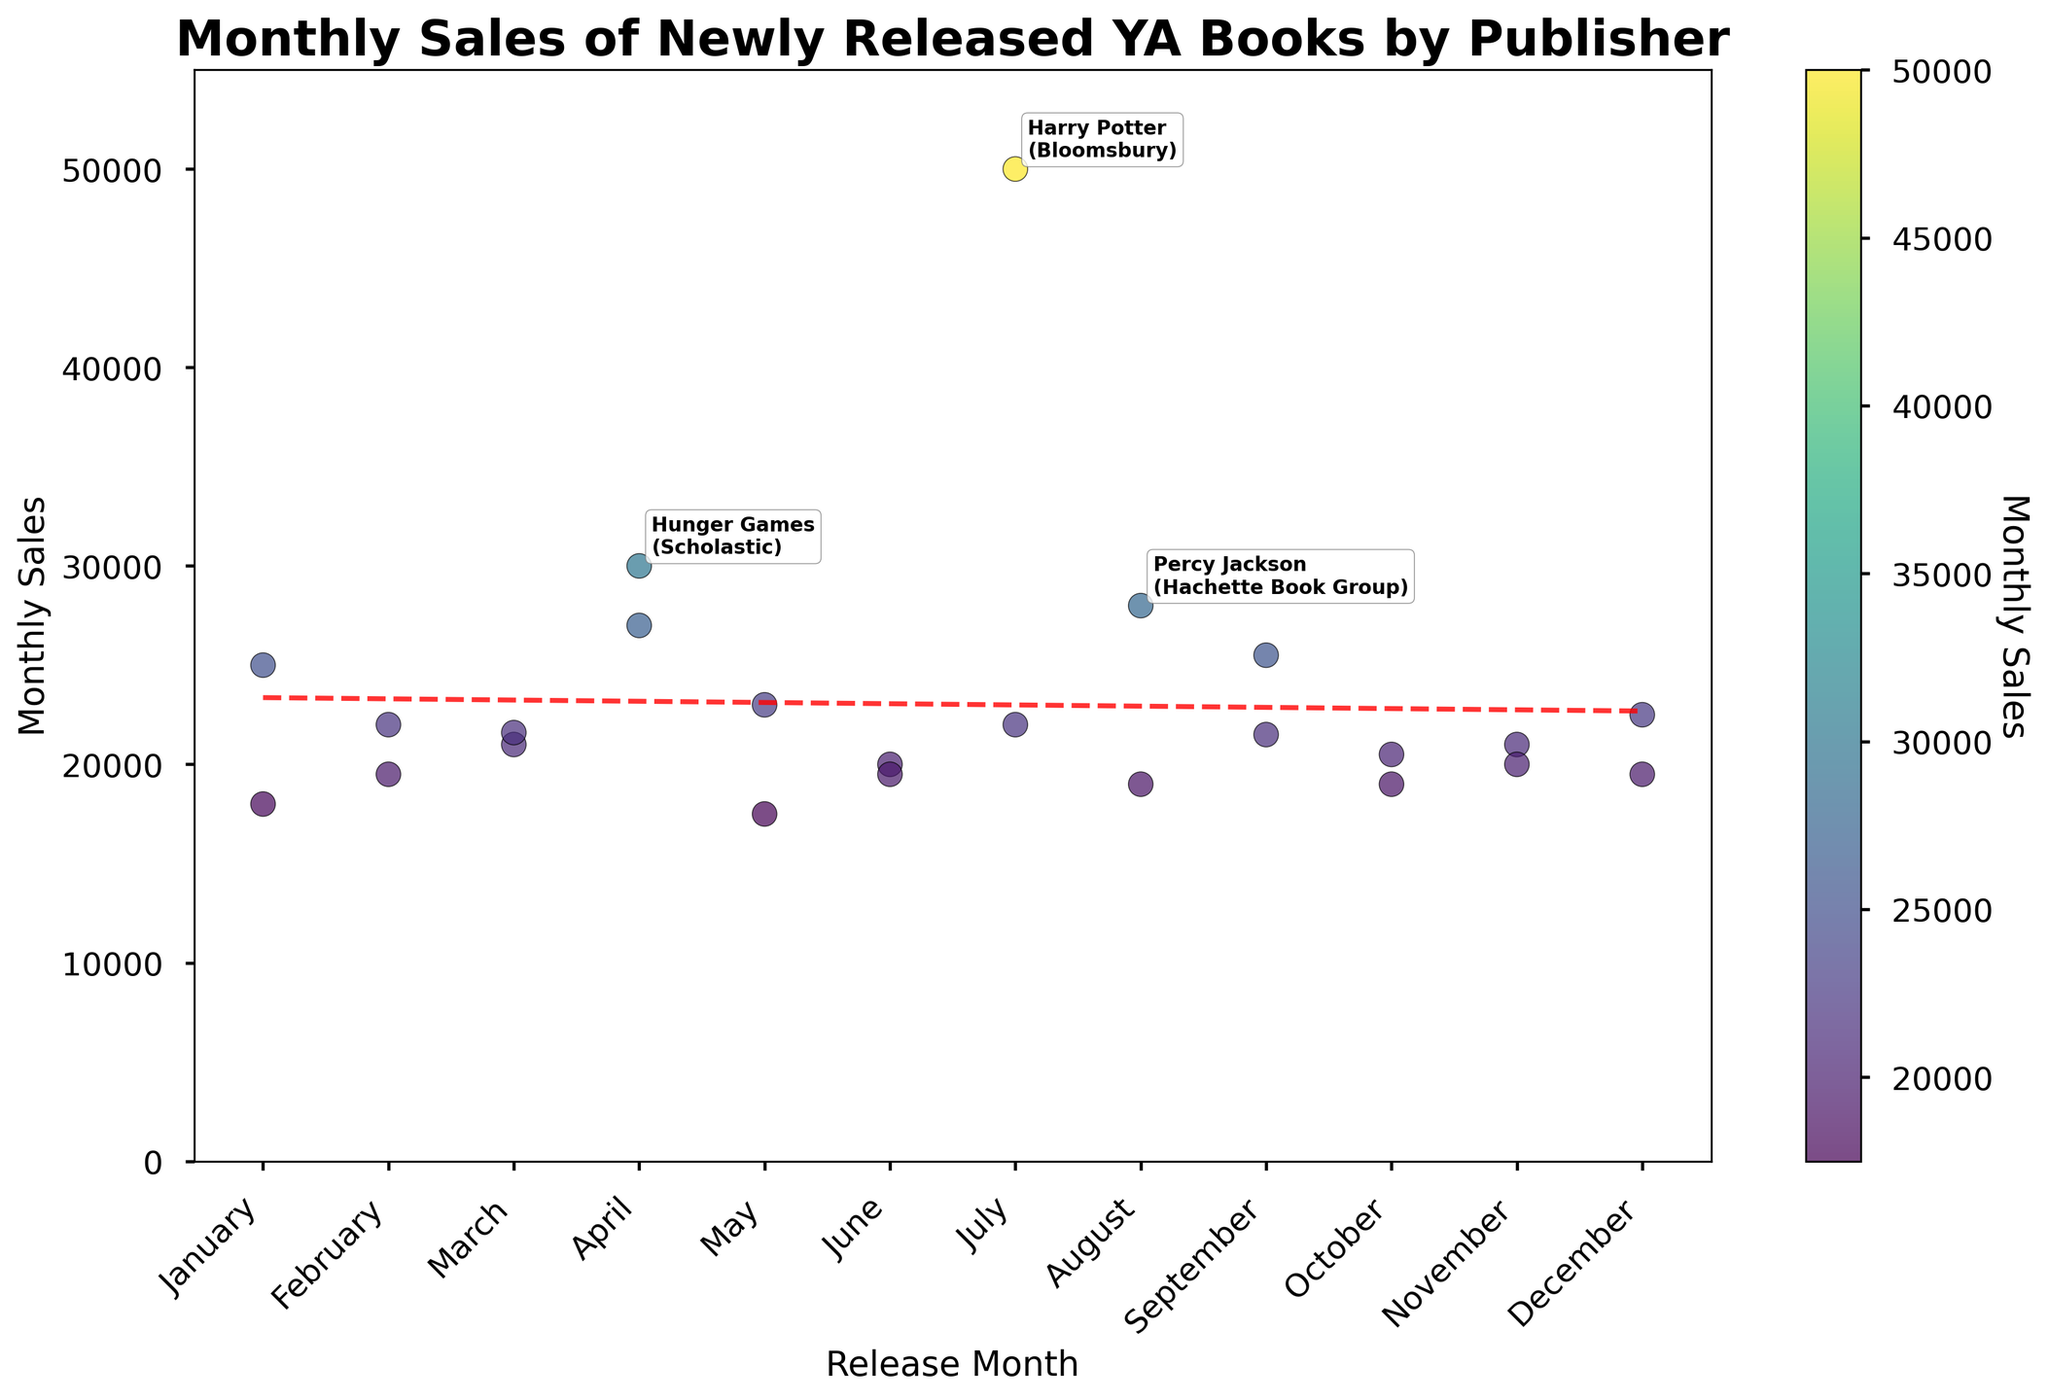What is the title of the plot? The title is typically displayed at the top of the plot. It summarizes the overall content or the main point of the visualization.
Answer: Monthly Sales of Newly Released YA Books by Publisher Which book had the highest monthly sales? The plot annotates the top 3 selling books with their Monthly Sales figures. The book with the highest Monthly Sales can be identified by the annotation with the highest value.
Answer: Harry Potter What is plotted on the x-axis of the scatter plot? The x-axis typically represents the explanatory variable, which in this case is labeled as "Release Month."
Answer: Release Month How many books were released in June? You can count the number of data points plotted at the location corresponding to June on the x-axis.
Answer: 2 What is the general trend shown by the trend line in the scatter plot? The trend line represents the overall direction of the data points. By observing its slope, one can tell if the trend is increasing, decreasing, or constant. In this case, you should refer to the line fitted among the points.
Answer: Slightly increasing Which month had the highest sales figure, and what was the amount? By examining the data points and looking for the highest value on the y-axis, one can determine the month with the highest sales and the corresponding amount. Annotated labels for top books assist with this.
Answer: July, 50,000 Compare "The Midnight Library" sales to "Six of Crows" in January. Which book had higher sales? By identifying the position of data points for "The Midnight Library" and "Six of Crows" at the location marked for January, one can compare their y-values.
Answer: The Midnight Library What is the average monthly sales for books released in April? Locate the data points plotted for the month of April and calculate the average of their y-values. Here it's a combination of two values, and their average should be computed.
Answer: (30000 + 27000) / 2 = 28,500 How does the trend line help in interpreting the overall sales trend over the months? The trend line summarizes the overall trend in the plotted data points. It highlights any general increase or decrease in the monthly sales figures over the months, showing the viewer a smoothed progression of the data.
Answer: It shows a slight increase in sales over time Are there any months where no books were released? By examining the x-axis and looking for months that have no data points, one can identify if there are any months without books released.
Answer: No 